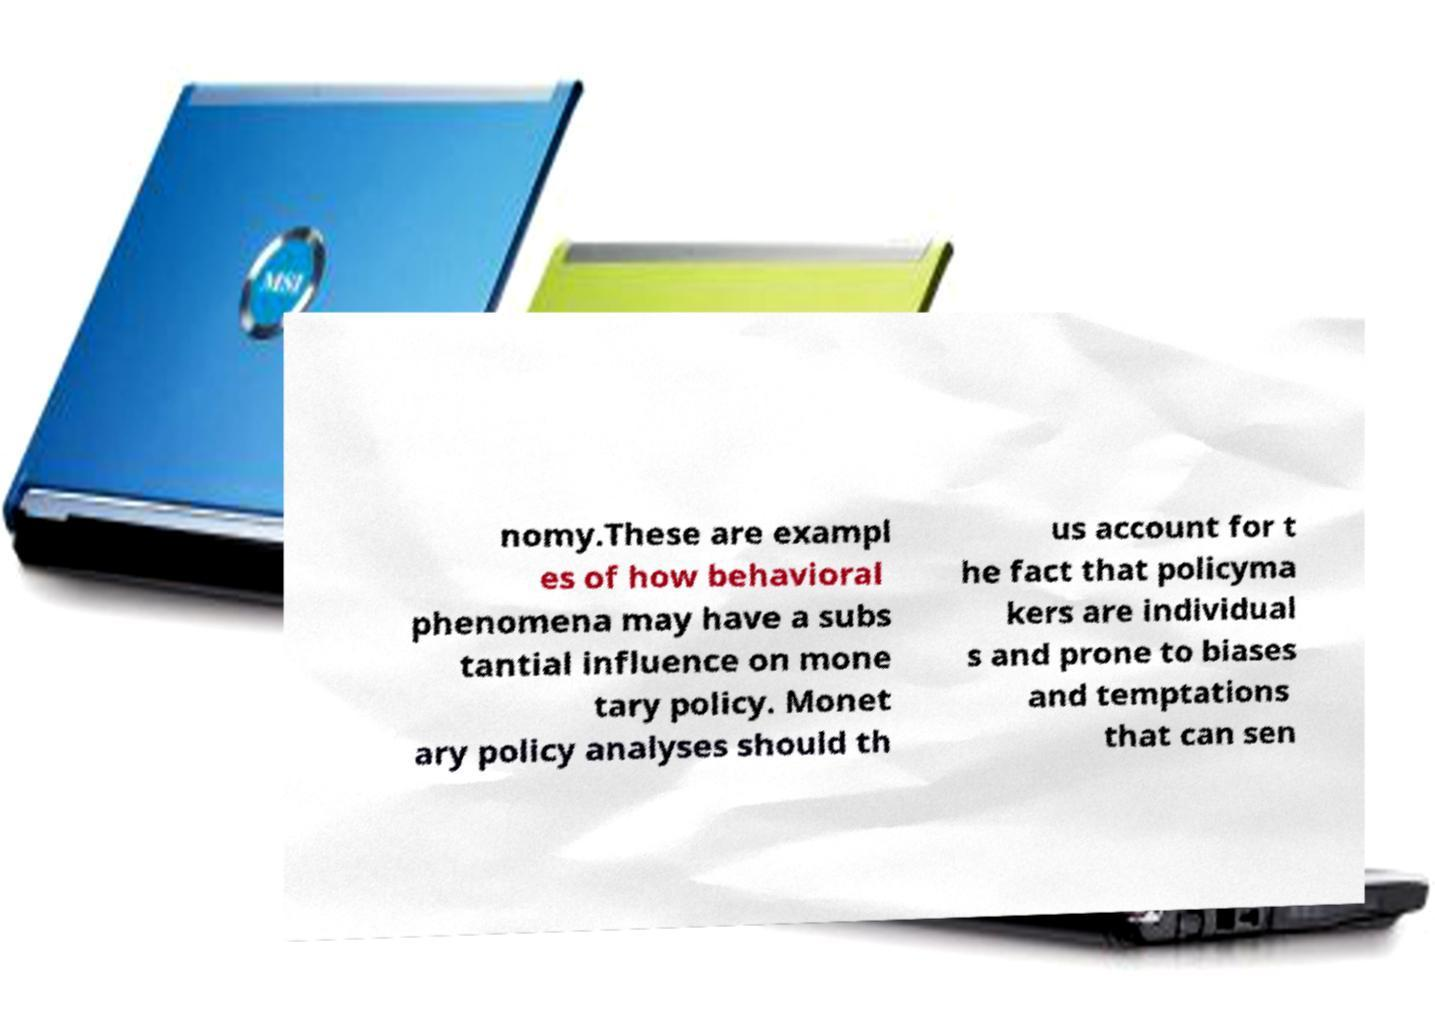Please identify and transcribe the text found in this image. nomy.These are exampl es of how behavioral phenomena may have a subs tantial influence on mone tary policy. Monet ary policy analyses should th us account for t he fact that policyma kers are individual s and prone to biases and temptations that can sen 